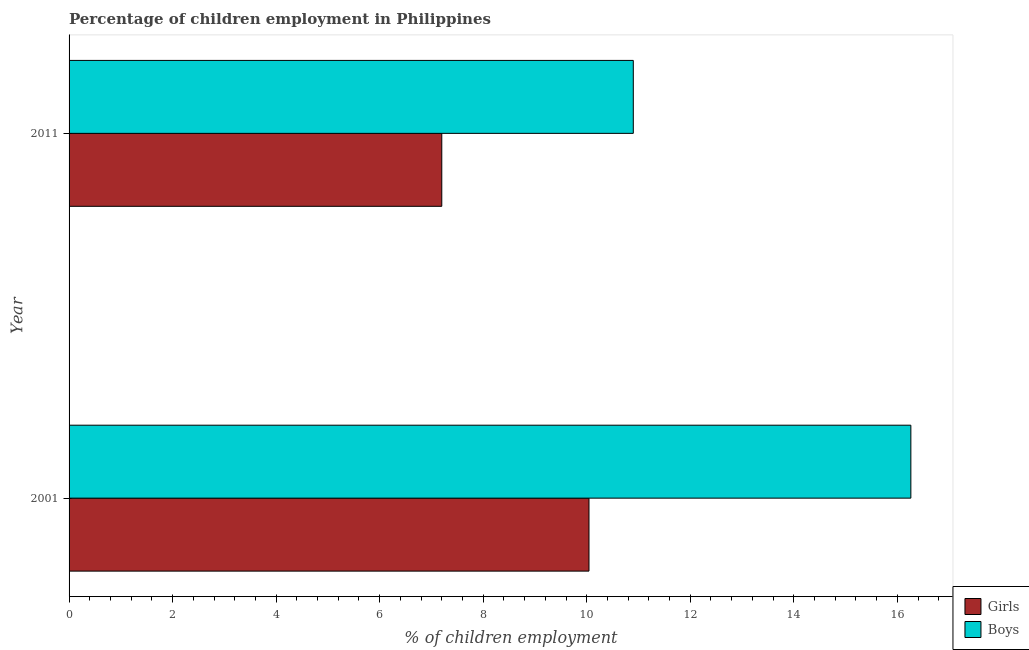Across all years, what is the maximum percentage of employed girls?
Your response must be concise. 10.04. Across all years, what is the minimum percentage of employed girls?
Provide a succinct answer. 7.2. In which year was the percentage of employed girls minimum?
Ensure brevity in your answer.  2011. What is the total percentage of employed boys in the graph?
Provide a short and direct response. 27.16. What is the difference between the percentage of employed boys in 2001 and that in 2011?
Your answer should be very brief. 5.36. What is the difference between the percentage of employed girls in 2011 and the percentage of employed boys in 2001?
Provide a short and direct response. -9.06. What is the average percentage of employed girls per year?
Give a very brief answer. 8.62. In the year 2001, what is the difference between the percentage of employed girls and percentage of employed boys?
Provide a short and direct response. -6.22. What is the ratio of the percentage of employed boys in 2001 to that in 2011?
Provide a short and direct response. 1.49. What does the 1st bar from the top in 2011 represents?
Ensure brevity in your answer.  Boys. What does the 2nd bar from the bottom in 2001 represents?
Your response must be concise. Boys. How many bars are there?
Keep it short and to the point. 4. Are all the bars in the graph horizontal?
Provide a short and direct response. Yes. How many years are there in the graph?
Your answer should be very brief. 2. Does the graph contain grids?
Offer a terse response. No. How many legend labels are there?
Your answer should be compact. 2. How are the legend labels stacked?
Your answer should be very brief. Vertical. What is the title of the graph?
Your response must be concise. Percentage of children employment in Philippines. What is the label or title of the X-axis?
Your answer should be compact. % of children employment. What is the % of children employment in Girls in 2001?
Your response must be concise. 10.04. What is the % of children employment in Boys in 2001?
Provide a short and direct response. 16.26. What is the % of children employment of Girls in 2011?
Provide a short and direct response. 7.2. What is the % of children employment in Boys in 2011?
Your answer should be compact. 10.9. Across all years, what is the maximum % of children employment in Girls?
Make the answer very short. 10.04. Across all years, what is the maximum % of children employment in Boys?
Give a very brief answer. 16.26. Across all years, what is the minimum % of children employment of Boys?
Offer a terse response. 10.9. What is the total % of children employment of Girls in the graph?
Keep it short and to the point. 17.24. What is the total % of children employment of Boys in the graph?
Offer a very short reply. 27.16. What is the difference between the % of children employment in Girls in 2001 and that in 2011?
Your answer should be very brief. 2.84. What is the difference between the % of children employment in Boys in 2001 and that in 2011?
Offer a terse response. 5.36. What is the difference between the % of children employment in Girls in 2001 and the % of children employment in Boys in 2011?
Give a very brief answer. -0.86. What is the average % of children employment in Girls per year?
Your answer should be very brief. 8.62. What is the average % of children employment in Boys per year?
Provide a short and direct response. 13.58. In the year 2001, what is the difference between the % of children employment of Girls and % of children employment of Boys?
Keep it short and to the point. -6.22. In the year 2011, what is the difference between the % of children employment of Girls and % of children employment of Boys?
Your answer should be very brief. -3.7. What is the ratio of the % of children employment of Girls in 2001 to that in 2011?
Ensure brevity in your answer.  1.4. What is the ratio of the % of children employment in Boys in 2001 to that in 2011?
Give a very brief answer. 1.49. What is the difference between the highest and the second highest % of children employment in Girls?
Offer a very short reply. 2.84. What is the difference between the highest and the second highest % of children employment of Boys?
Keep it short and to the point. 5.36. What is the difference between the highest and the lowest % of children employment in Girls?
Provide a short and direct response. 2.84. What is the difference between the highest and the lowest % of children employment of Boys?
Offer a very short reply. 5.36. 